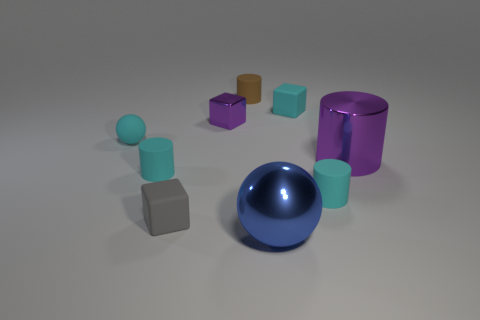Are there any objects that stand out due to their unique shape? Yes, the tall cylindrical object on the right stands out because it has a different shape compared to the other round and cube-shaped objects in the image. 